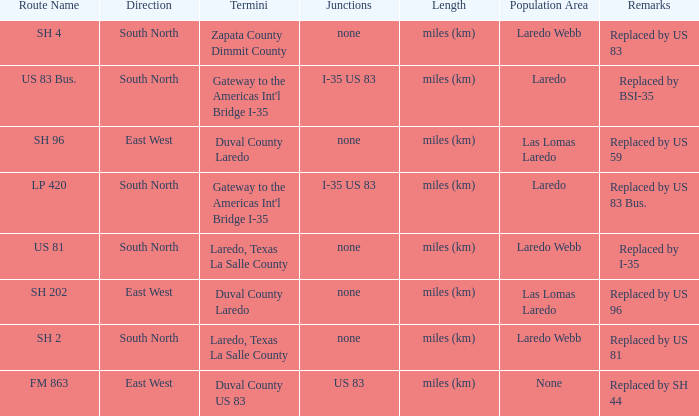How many termini are there that have "east west" listed in their direction section, "none" listed in their junction section, and have a route name of "sh 202"? 1.0. Can you parse all the data within this table? {'header': ['Route Name', 'Direction', 'Termini', 'Junctions', 'Length', 'Population Area', 'Remarks'], 'rows': [['SH 4', 'South North', 'Zapata County Dimmit County', 'none', 'miles (km)', 'Laredo Webb', 'Replaced by US 83'], ['US 83 Bus.', 'South North', "Gateway to the Americas Int'l Bridge I-35", 'I-35 US 83', 'miles (km)', 'Laredo', 'Replaced by BSI-35'], ['SH 96', 'East West', 'Duval County Laredo', 'none', 'miles (km)', 'Las Lomas Laredo', 'Replaced by US 59'], ['LP 420', 'South North', "Gateway to the Americas Int'l Bridge I-35", 'I-35 US 83', 'miles (km)', 'Laredo', 'Replaced by US 83 Bus.'], ['US 81', 'South North', 'Laredo, Texas La Salle County', 'none', 'miles (km)', 'Laredo Webb', 'Replaced by I-35'], ['SH 202', 'East West', 'Duval County Laredo', 'none', 'miles (km)', 'Las Lomas Laredo', 'Replaced by US 96'], ['SH 2', 'South North', 'Laredo, Texas La Salle County', 'none', 'miles (km)', 'Laredo Webb', 'Replaced by US 81'], ['FM 863', 'East West', 'Duval County US 83', 'US 83', 'miles (km)', 'None', 'Replaced by SH 44']]} 